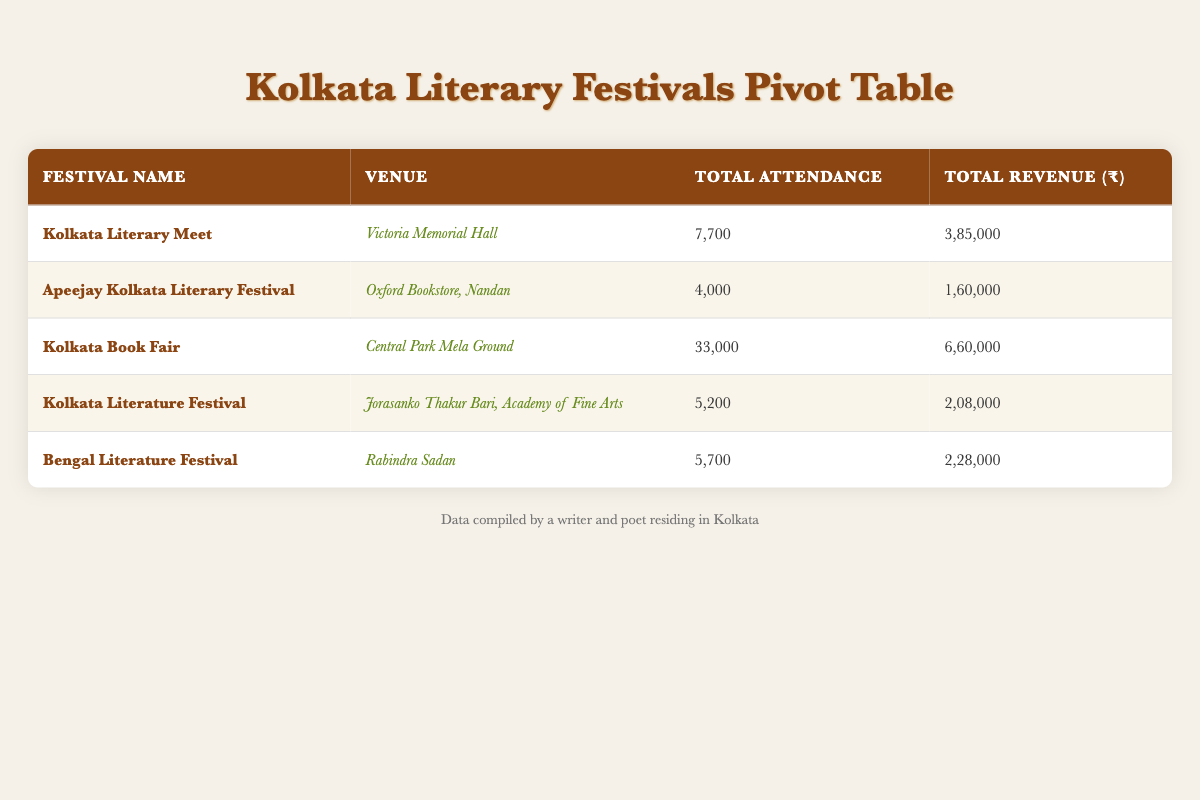What is the total attendance for the Kolkata Book Fair? The table shows that the total attendance for the Kolkata Book Fair at Central Park Mela Ground is 33,000.
Answer: 33,000 Which festival had the highest ticket revenue? By comparing the total revenue from each festival in the table, Kolkata Book Fair has the highest revenue of ₹660,000.
Answer: Kolkata Book Fair How many more attendees did the Kolkata Literary Meet have than the Bengal Literature Festival? The Kolkata Literary Meet had a total attendance of 7,700, while the Bengal Literature Festival had 5,700. The difference is 7,700 - 5,700 = 2,000.
Answer: 2,000 Is the total revenue for the Kolkata Literature Festival greater than that for the Apeejay Kolkata Literary Festival? The Kolkata Literature Festival generated a total revenue of ₹208,000, whereas the Apeejay Kolkata Literary Festival generated ₹160,000. Since 208,000 is greater than 160,000, the statement is true.
Answer: Yes What is the average attendance across all festivals listed in the table? To find the average attendance, first sum up the total attendance: 7,700 + 4,000 + 33,000 + 5,200 + 5,700 = 55,600. Then divide this by the number of festivals, which is 5. Therefore, 55,600 / 5 = 11,120.
Answer: 11,120 Which venue had the highest total attendance? The Central Park Mela Ground hosted the Kolkata Book Fair, which had the highest attendance of 33,000. No other venue's attendance matches or exceeds this number.
Answer: Central Park Mela Ground Did the Rabindra Sadan venue have more attendees on May 21 than on May 20? On May 20, the attendance was 2,500, and on May 21, it was 3,200. Since 3,200 is greater than 2,500, the statement is true.
Answer: Yes How much total revenue was earned from events at the Victoria Memorial Hall? The total revenue from events at the Victoria Memorial Hall includes the revenues from both days (₹385,000). Adding these gives ₹385,000 as the total revenue from that venue.
Answer: ₹385,000 What is the difference in total attendance between the Kolkata Literary Meet and the Kolkata Literature Festival? The total attendance for the Kolkata Literary Meet is 7,700, and for the Kolkata Literature Festival is 5,200. The difference is 7,700 - 5,200 = 2,500.
Answer: 2,500 